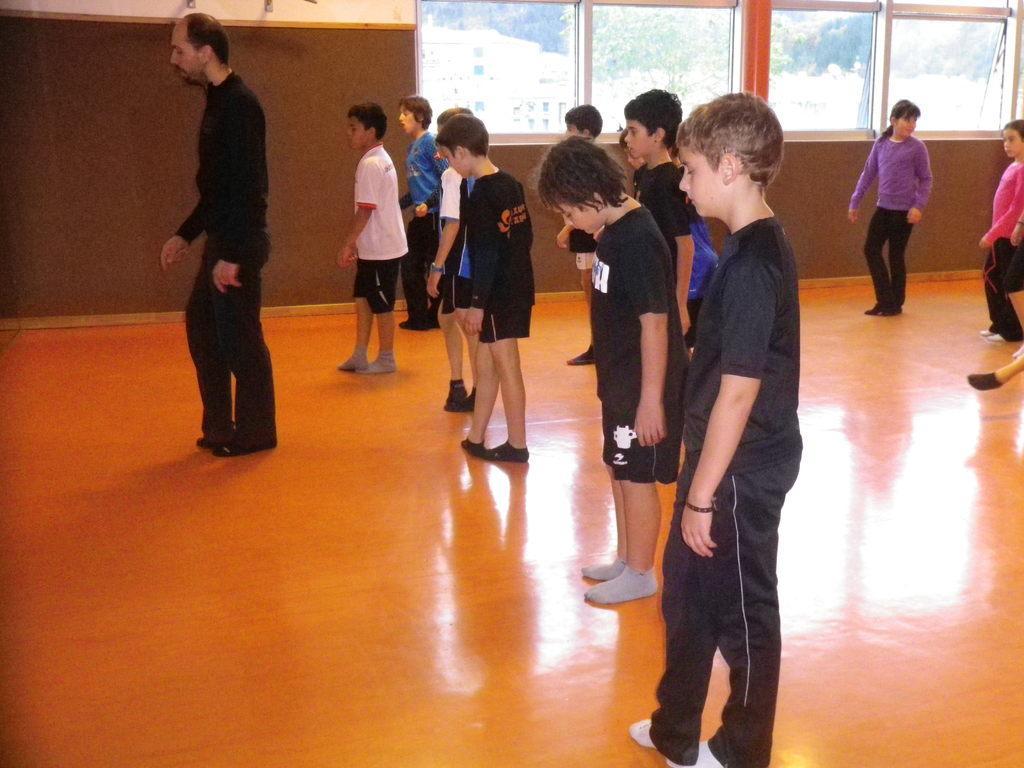Describe this image in one or two sentences. In this image there are people standing on the floor. In the background of the image there is a wall. There are glass windows through which we can see trees and buildings. 